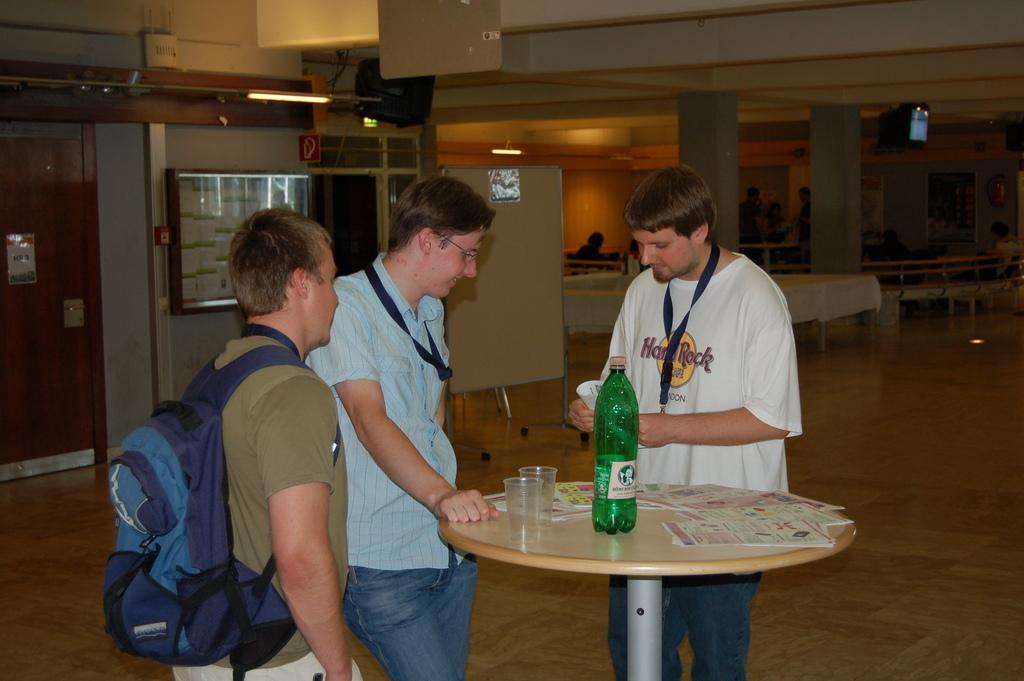Describe this image in one or two sentences. There are three men standing. The men in green t-shirt is wearing a bag. In front of them there is a table. On that table there is a bottle, paper and glass. Behind them there is a door. And to the right corner there are some benches and the pillar. There is a TV on the top. 